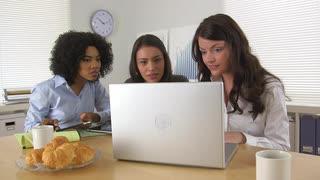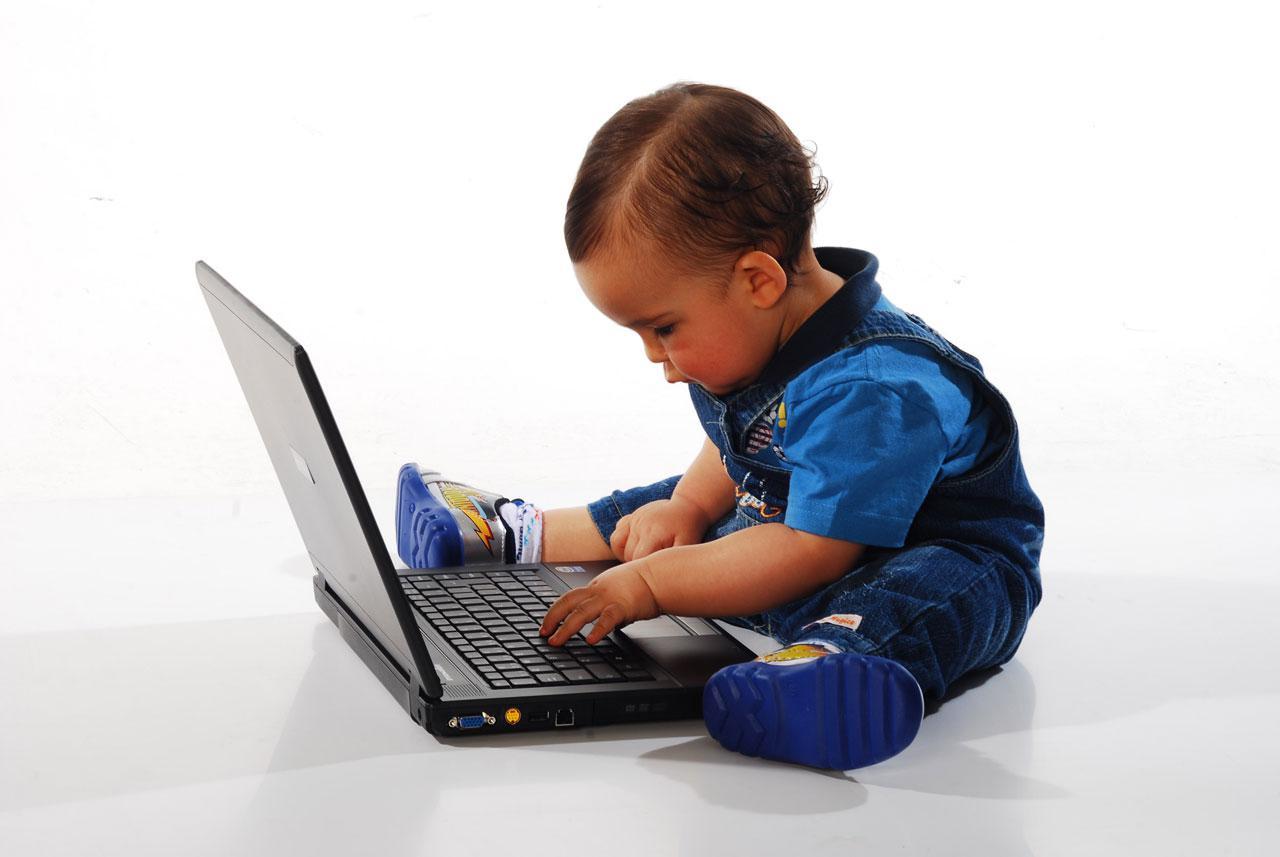The first image is the image on the left, the second image is the image on the right. Examine the images to the left and right. Is the description "One image shows a row of three young women sitting behind one open laptop, and the other image shows a baby boy with a hand on the keyboard of an open laptop." accurate? Answer yes or no. Yes. The first image is the image on the left, the second image is the image on the right. Evaluate the accuracy of this statement regarding the images: "In one photo, a young child interacts with a laptop and in the other photo, three women look at a single laptop.". Is it true? Answer yes or no. Yes. 